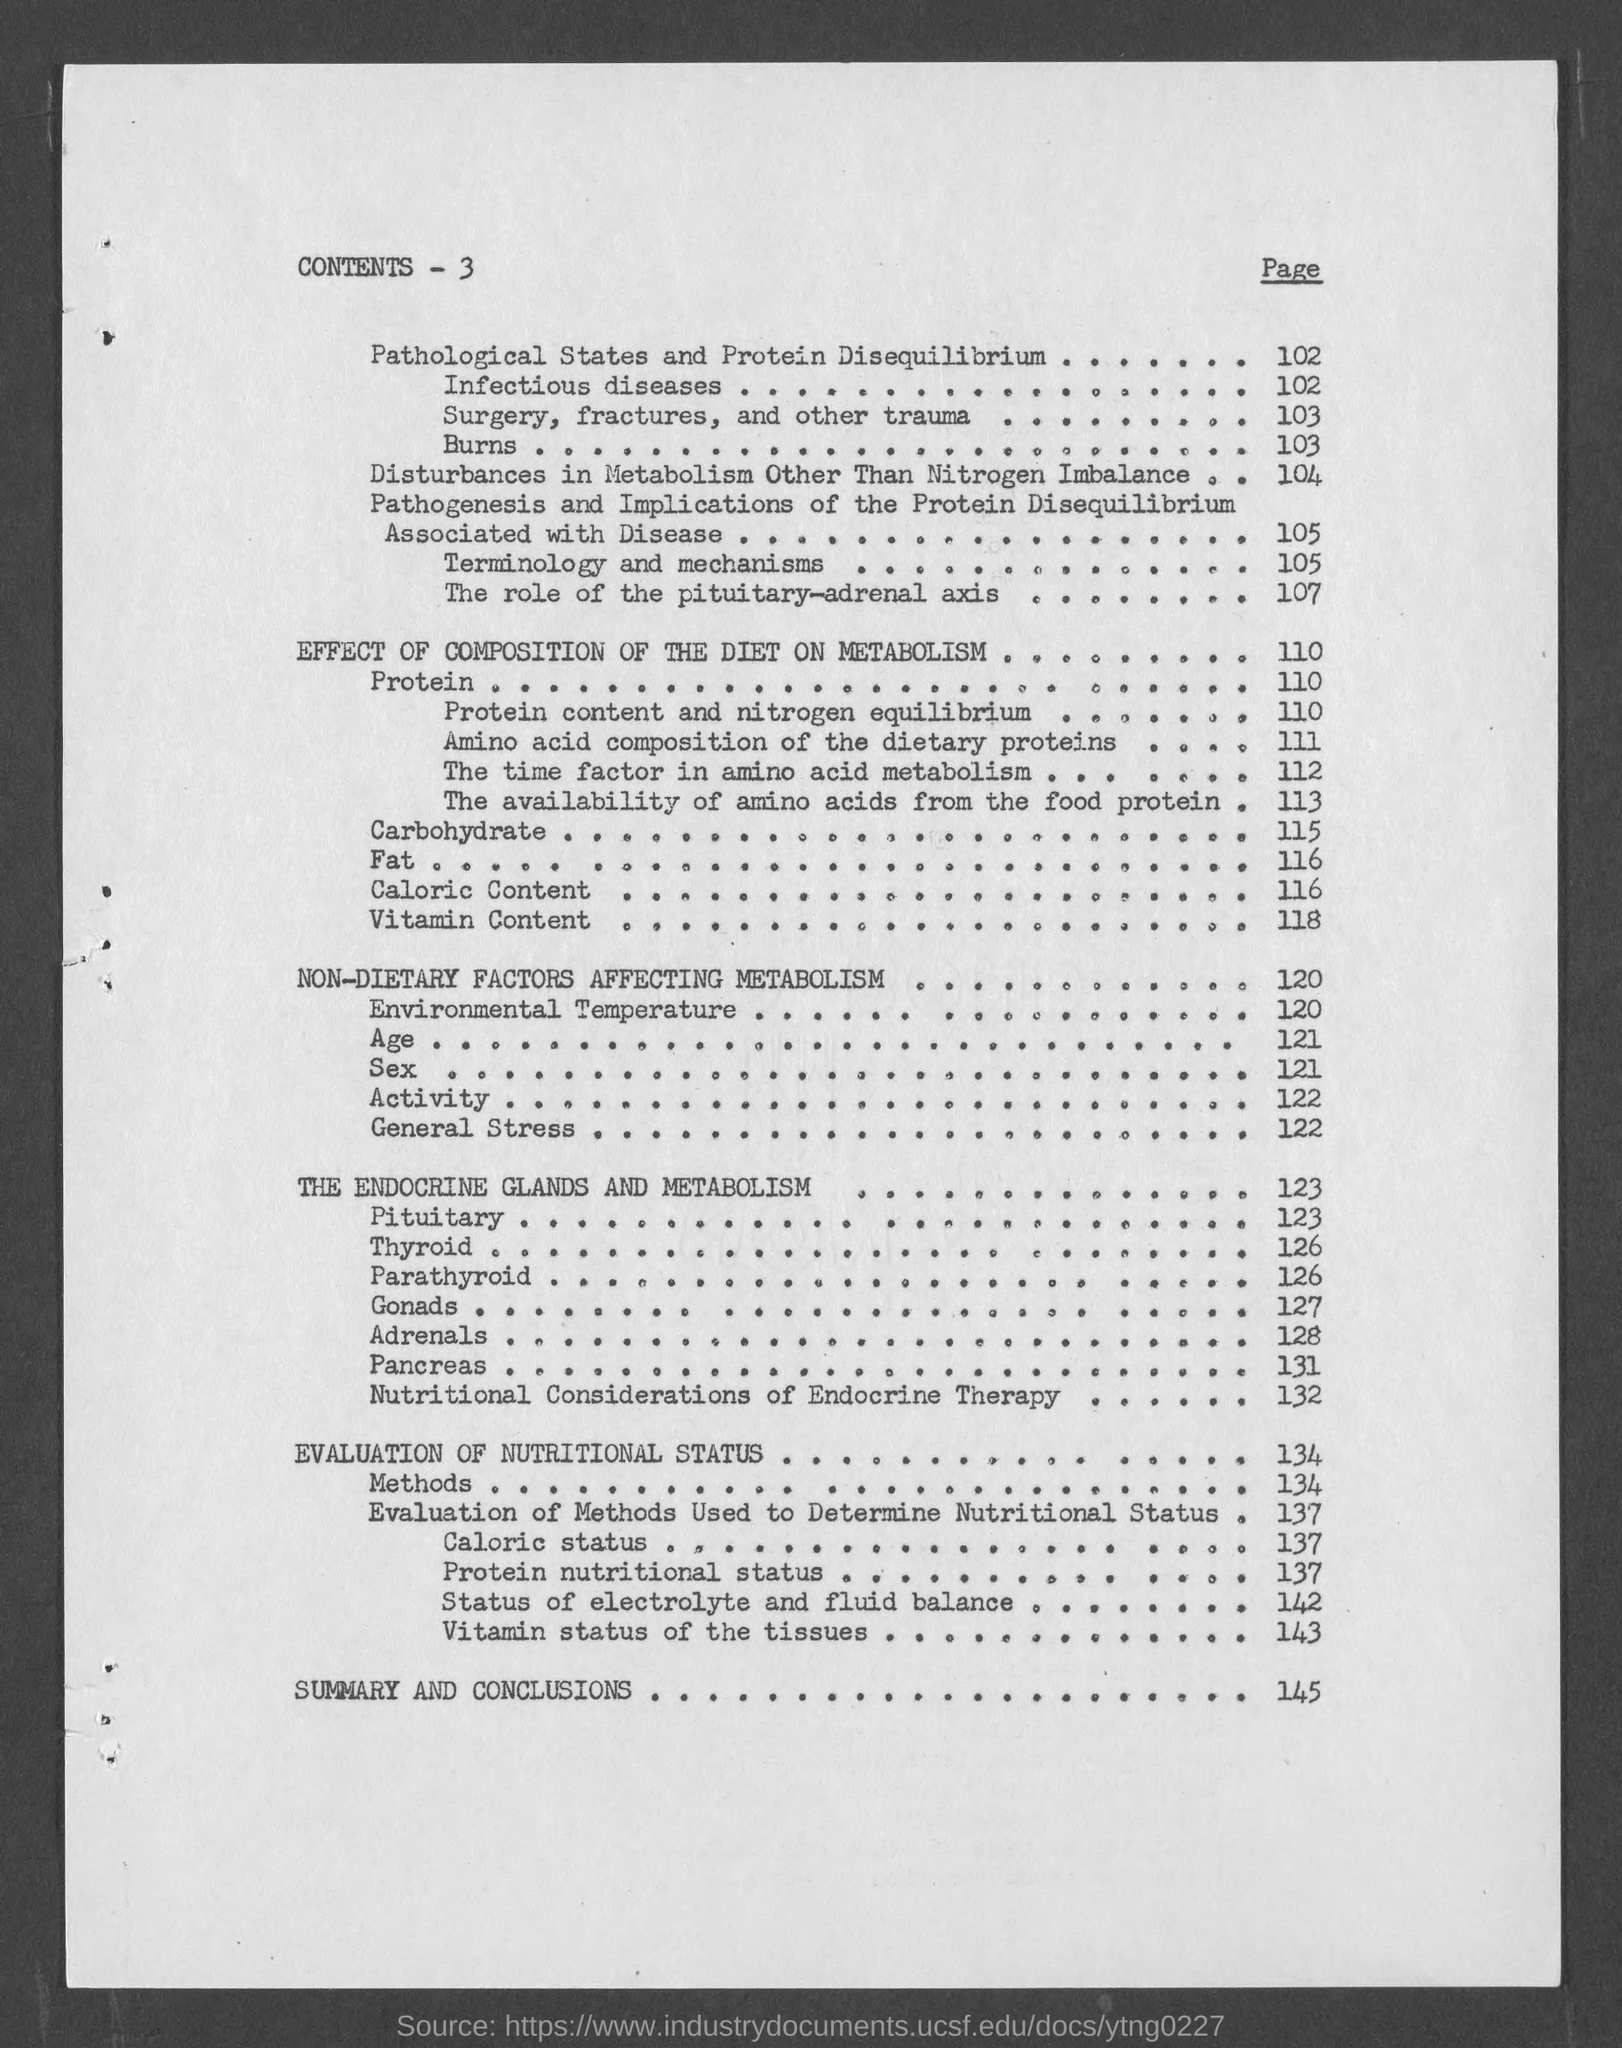Give some essential details in this illustration. The page number for Adrenals is 128. The page number for Pancreas is 131. The page number for environmental temperature is 120. The heading of the page is 'Contents - 3..', which provides a summary of the information that can be found within the page. The page number for The Endocrine Glands and Metabolism is 123. 